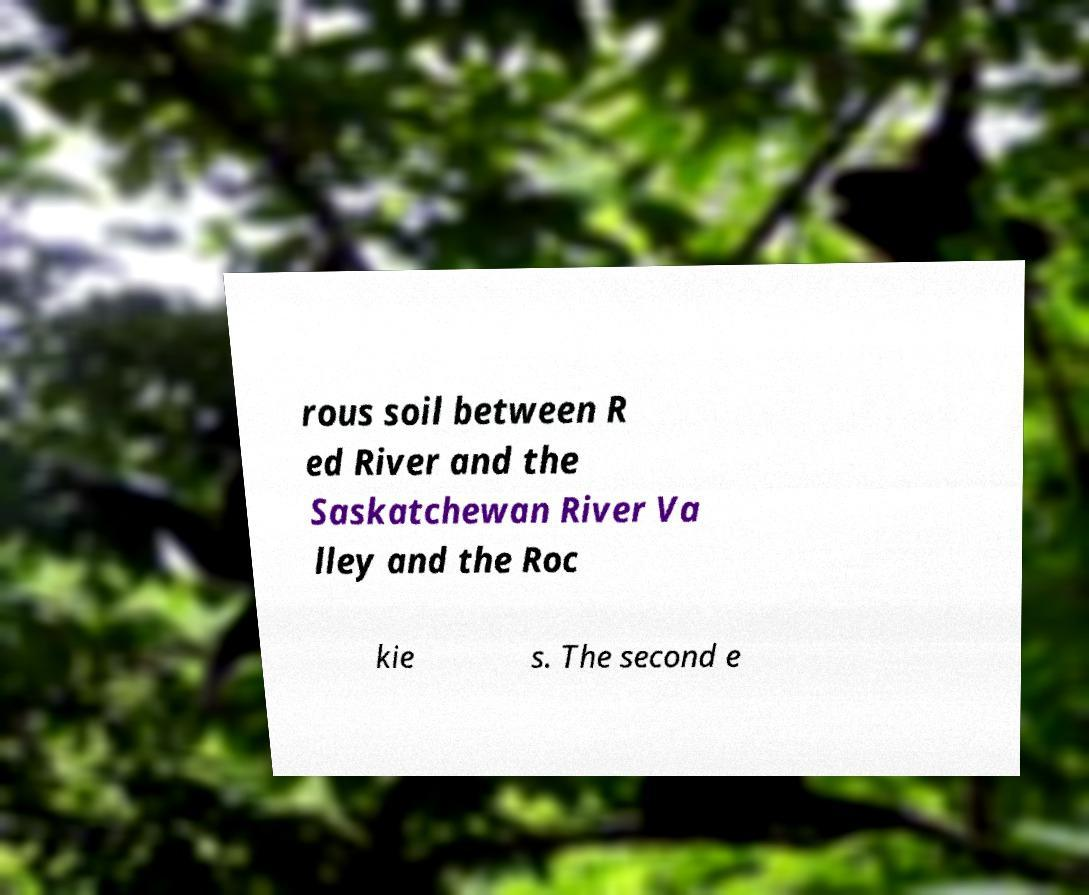For documentation purposes, I need the text within this image transcribed. Could you provide that? rous soil between R ed River and the Saskatchewan River Va lley and the Roc kie s. The second e 